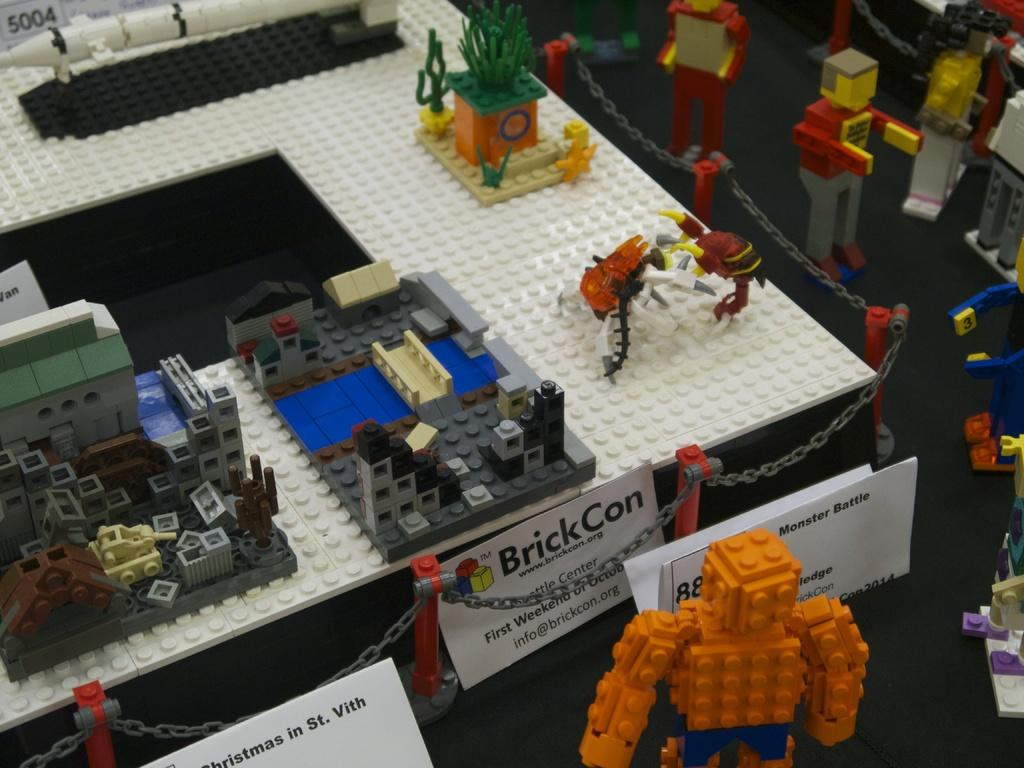What type of toys are present in the image? There are Lego toys in the image. What else can be seen in the image besides the toys? There are papers with text in the image. What type of comb is used to style the hair in the image? There is no hair or comb present in the image; it features Lego toys and papers with text. 